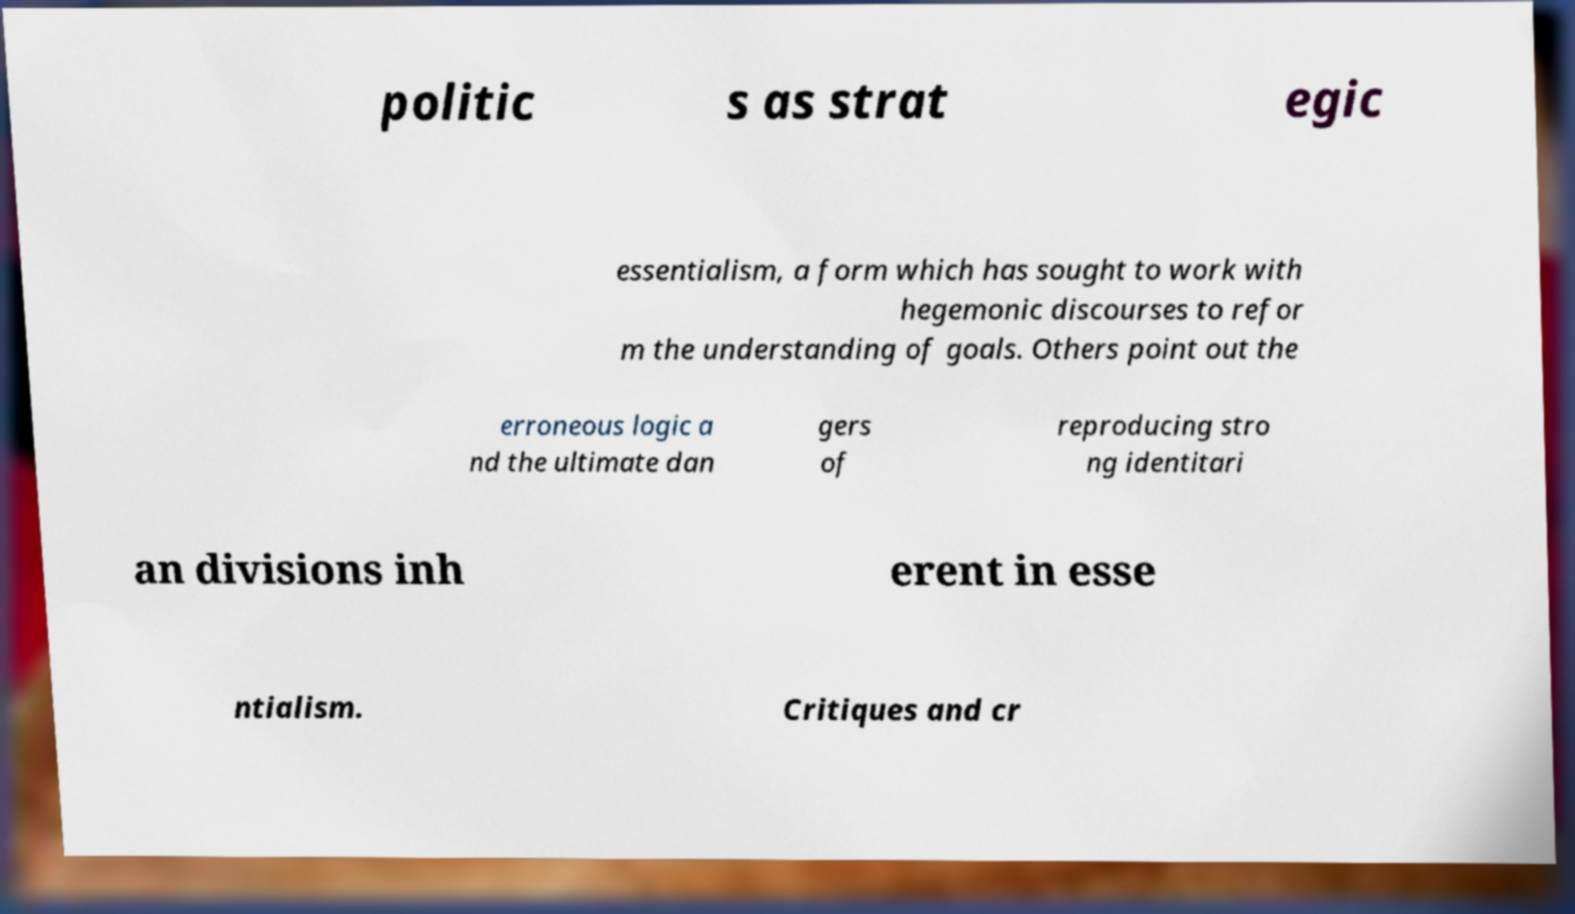Could you extract and type out the text from this image? politic s as strat egic essentialism, a form which has sought to work with hegemonic discourses to refor m the understanding of goals. Others point out the erroneous logic a nd the ultimate dan gers of reproducing stro ng identitari an divisions inh erent in esse ntialism. Critiques and cr 